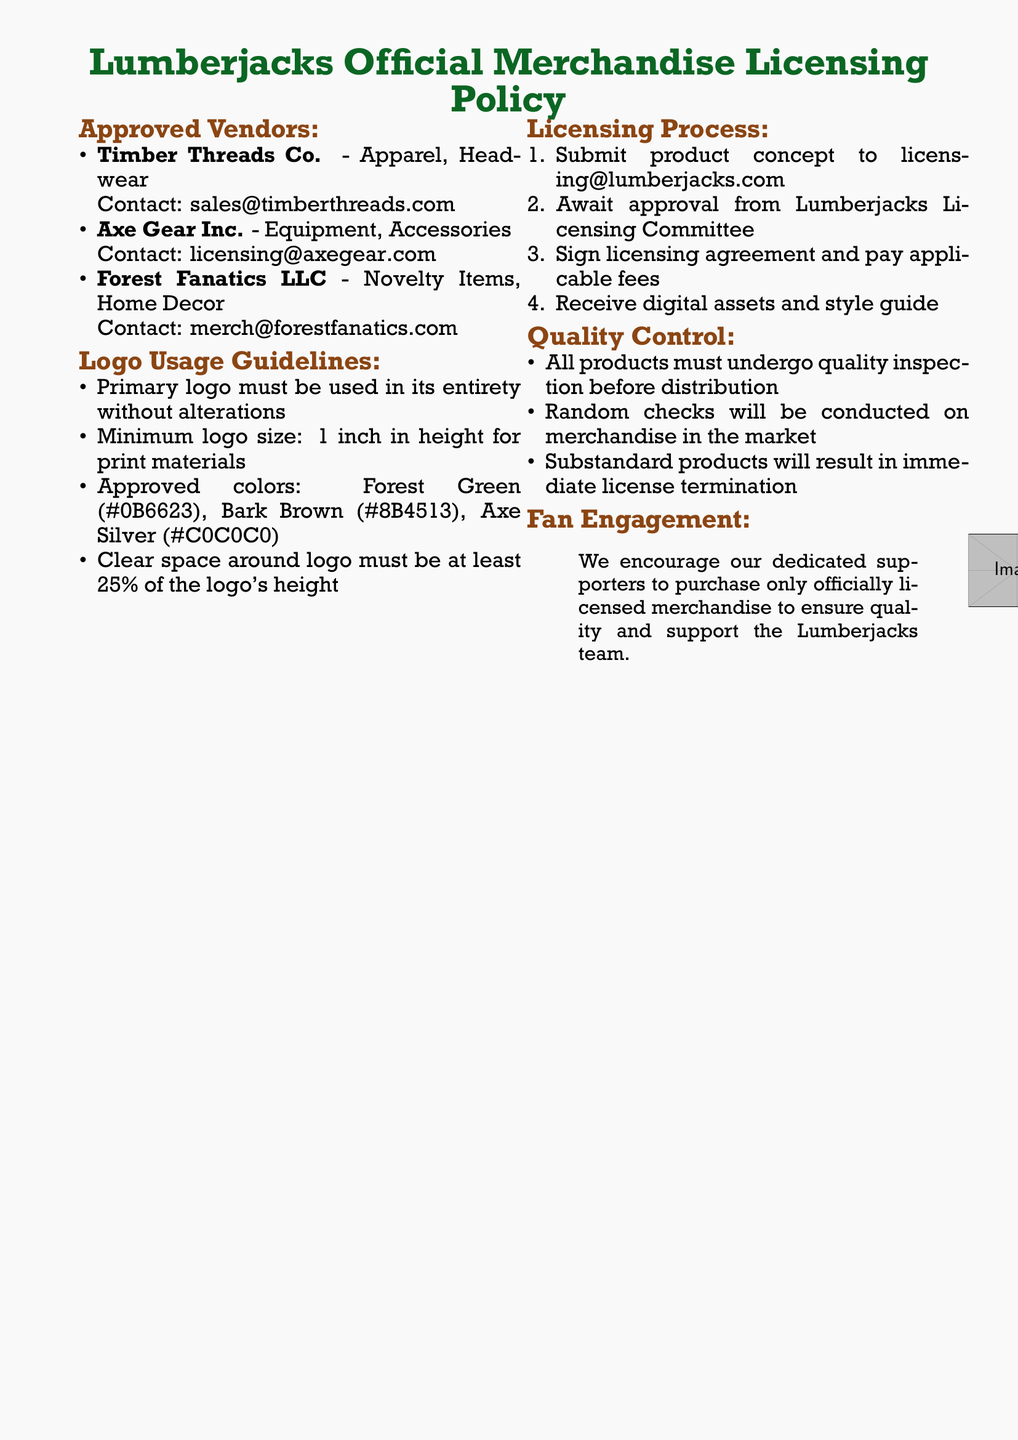What is the name of the approved vendor for apparel? The document lists Timber Threads Co. as the approved vendor for apparel.
Answer: Timber Threads Co What is the minimum logo size for print materials? According to the guidelines, the minimum logo size must be 1 inch in height for print materials.
Answer: 1 inch Who should product concepts be submitted to? The document states that product concepts should be submitted to licensing@lumberjacks.com.
Answer: licensing@lumberjacks.com What is the color code for Forest Green? The guidelines specify that the color code for Forest Green is #0B6623.
Answer: #0B6623 What happens to substandard products? The document indicates that substandard products will result in immediate license termination.
Answer: Immediate license termination How many approved vendors are listed in the document? The document contains three approved vendors for merchandise licensing.
Answer: Three What is the purpose of the quality inspection mentioned in the document? Quality inspection is required to ensure all products meet the standards before distribution.
Answer: Ensure quality What is encouraged for dedicated supporters? The document states that dedicated supporters are encouraged to purchase only officially licensed merchandise.
Answer: Only officially licensed merchandise 